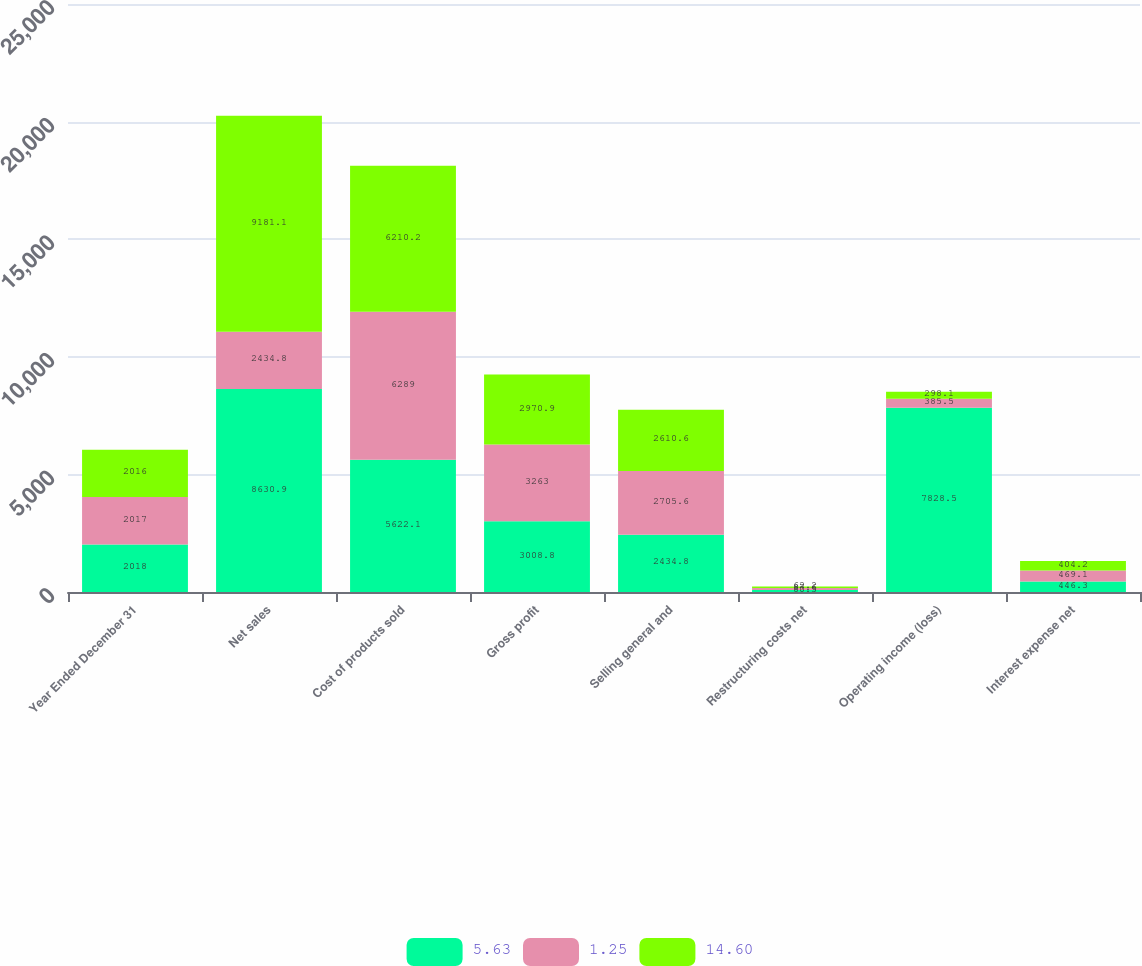<chart> <loc_0><loc_0><loc_500><loc_500><stacked_bar_chart><ecel><fcel>Year Ended December 31<fcel>Net sales<fcel>Cost of products sold<fcel>Gross profit<fcel>Selling general and<fcel>Restructuring costs net<fcel>Operating income (loss)<fcel>Interest expense net<nl><fcel>5.63<fcel>2018<fcel>8630.9<fcel>5622.1<fcel>3008.8<fcel>2434.8<fcel>80.5<fcel>7828.5<fcel>446.3<nl><fcel>1.25<fcel>2017<fcel>2434.8<fcel>6289<fcel>3263<fcel>2705.6<fcel>87.6<fcel>385.5<fcel>469.1<nl><fcel>14.6<fcel>2016<fcel>9181.1<fcel>6210.2<fcel>2970.9<fcel>2610.6<fcel>62.2<fcel>298.1<fcel>404.2<nl></chart> 